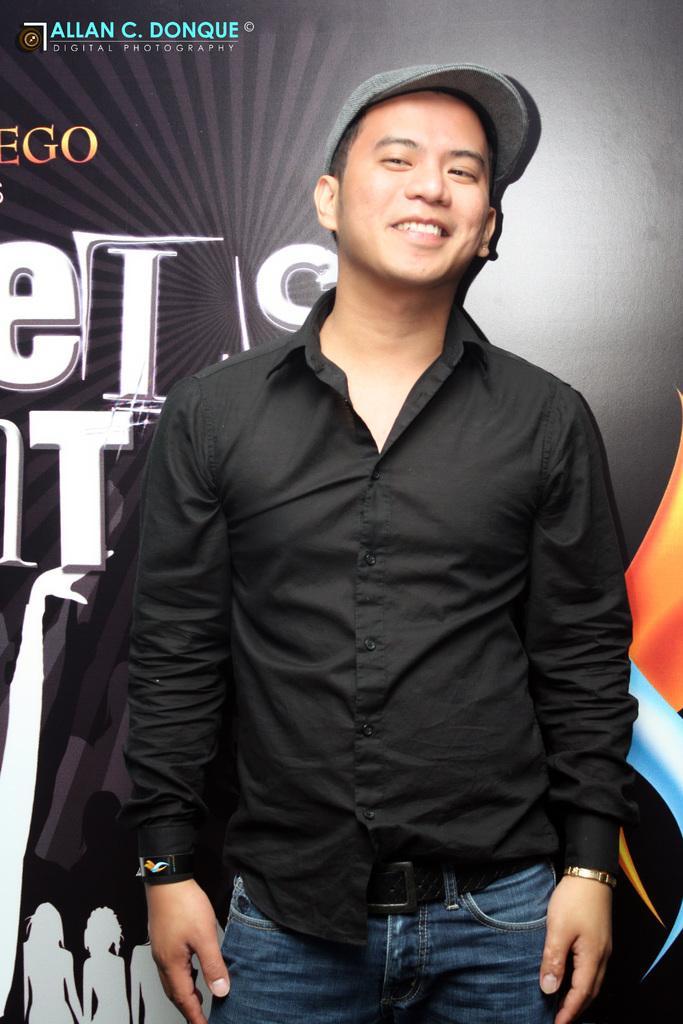Please provide a concise description of this image. This image is clicked inside. In this image, there is a man standing and wearing a black shirt and blue jeans along with a cap. In the background, there is a banner in black color. 